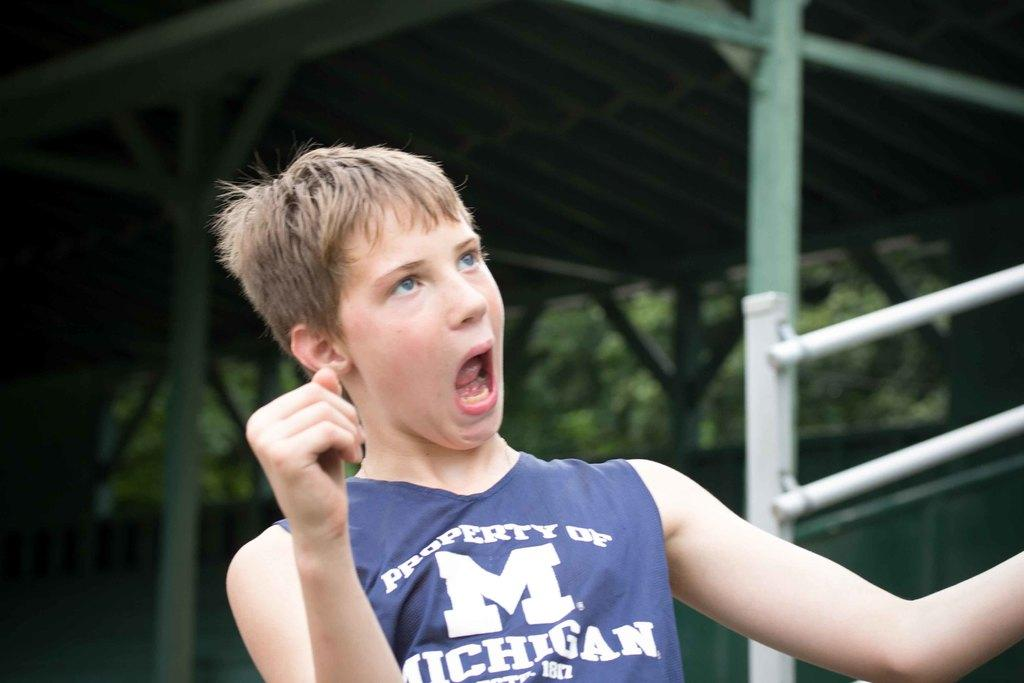<image>
Give a short and clear explanation of the subsequent image. A male is wearing a "Property of Michigan" jersey and making a funny face. 